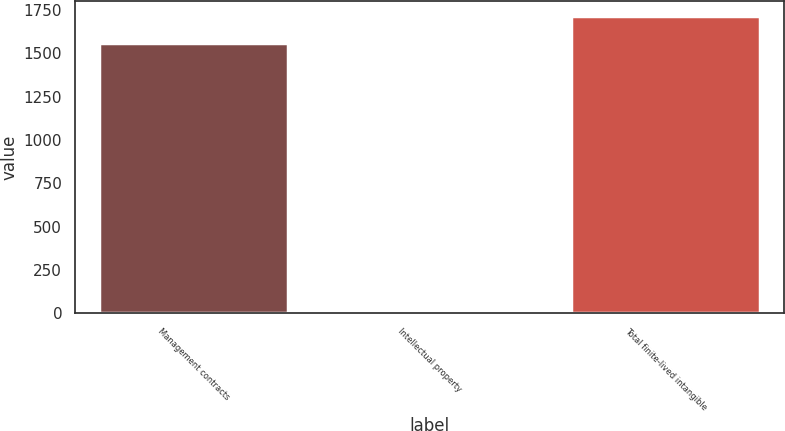Convert chart. <chart><loc_0><loc_0><loc_500><loc_500><bar_chart><fcel>Management contracts<fcel>Intellectual property<fcel>Total finite-lived intangible<nl><fcel>1561<fcel>6<fcel>1717.1<nl></chart> 